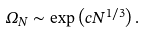<formula> <loc_0><loc_0><loc_500><loc_500>\Omega _ { N } \sim \exp \left ( c N ^ { 1 / 3 } \right ) .</formula> 